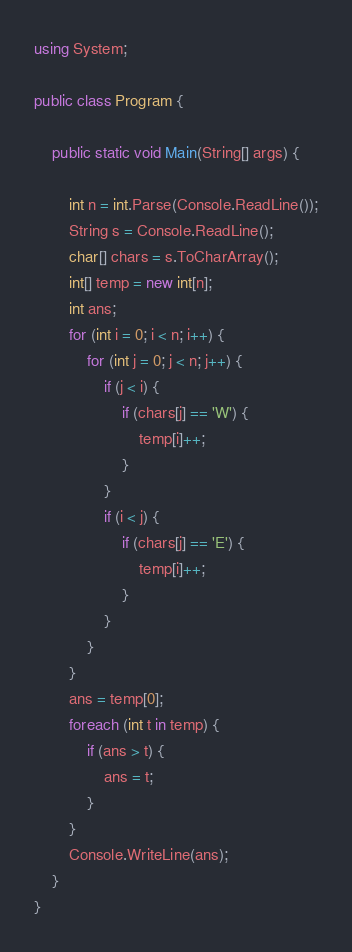<code> <loc_0><loc_0><loc_500><loc_500><_C#_>using System;

public class Program {

    public static void Main(String[] args) {

        int n = int.Parse(Console.ReadLine());
        String s = Console.ReadLine();
        char[] chars = s.ToCharArray();
        int[] temp = new int[n];
        int ans;
        for (int i = 0; i < n; i++) {
            for (int j = 0; j < n; j++) {
                if (j < i) {
                    if (chars[j] == 'W') {
                        temp[i]++;
                    }
                }
                if (i < j) {
                    if (chars[j] == 'E') {
                        temp[i]++;
                    }
                }
            }
        }
        ans = temp[0];
        foreach (int t in temp) {
            if (ans > t) {
                ans = t;
            }
        }
        Console.WriteLine(ans);
    }
}</code> 